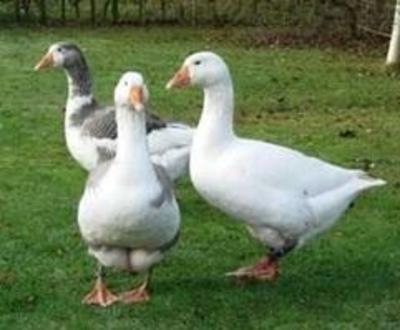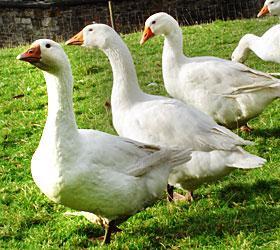The first image is the image on the left, the second image is the image on the right. For the images displayed, is the sentence "There are exactly three ducks in the left image." factually correct? Answer yes or no. Yes. The first image is the image on the left, the second image is the image on the right. Considering the images on both sides, is "There are more birds in the image on the left than in the image on the right." valid? Answer yes or no. No. 